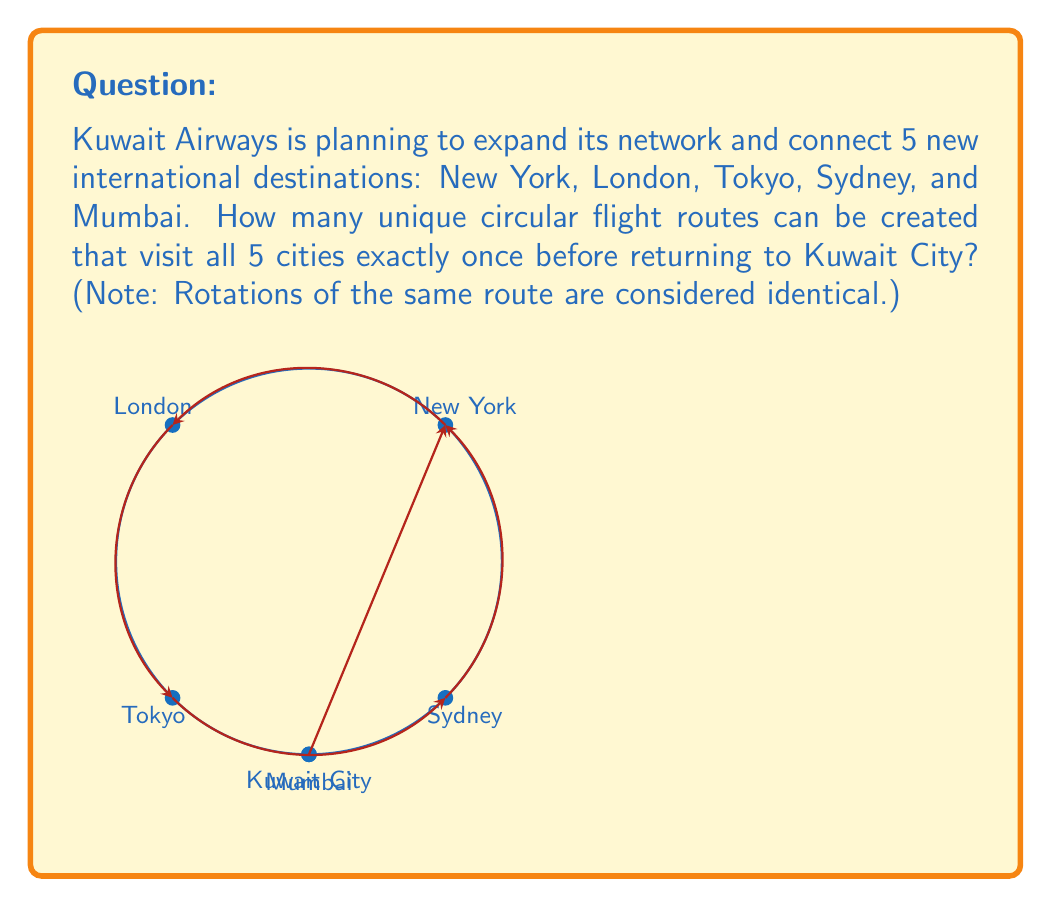Solve this math problem. Let's approach this step-by-step using concepts from permutation groups:

1) First, we need to understand that this is a circular permutation problem. The route starts and ends in Kuwait City, so we're only concerned with the order of the 5 new destinations.

2) For a regular permutation of 5 cities, we would have 5! = 120 possibilities.

3) However, in a circular permutation, rotations of the same route are considered identical. For example, New York → London → Tokyo → Sydney → Mumbai is the same as London → Tokyo → Sydney → Mumbai → New York.

4) In group theory, this is equivalent to considering the orbit of each permutation under the action of the cyclic group $C_5$ (rotations).

5) The number of unique circular permutations is given by the formula:

   $$\text{Number of unique circular permutations} = \frac{(n-1)!}{1}$$

   Where $n$ is the number of elements being permuted.

6) In this case, $n = 5$, so we have:

   $$\text{Number of unique circular flight routes} = \frac{(5-1)!}{1} = \frac{4!}{1} = 24$$

Therefore, Kuwait Airways can create 24 unique circular flight routes that visit all 5 new destinations exactly once before returning to Kuwait City.
Answer: 24 unique circular flight routes 